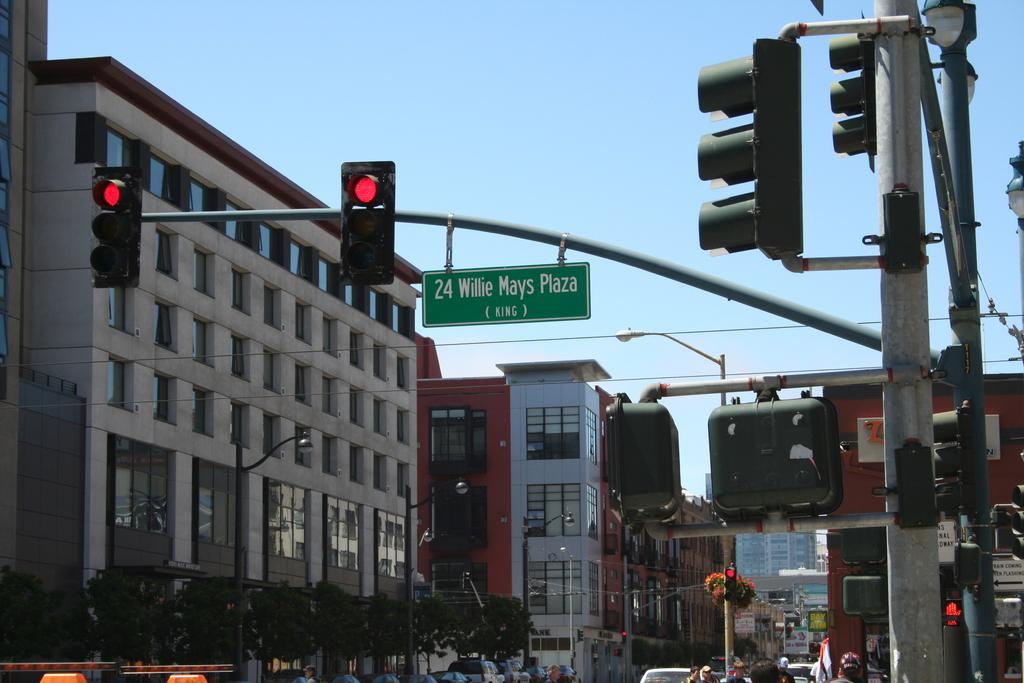<image>
Describe the image concisely. A street sign for 24 Willie Mays Plaza hangs over the road. 